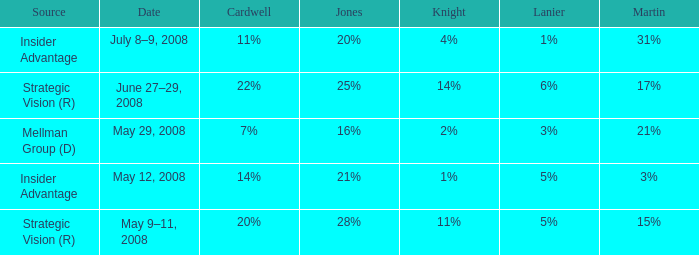Which martin event took place on july 8-9, 2008? 31%. 